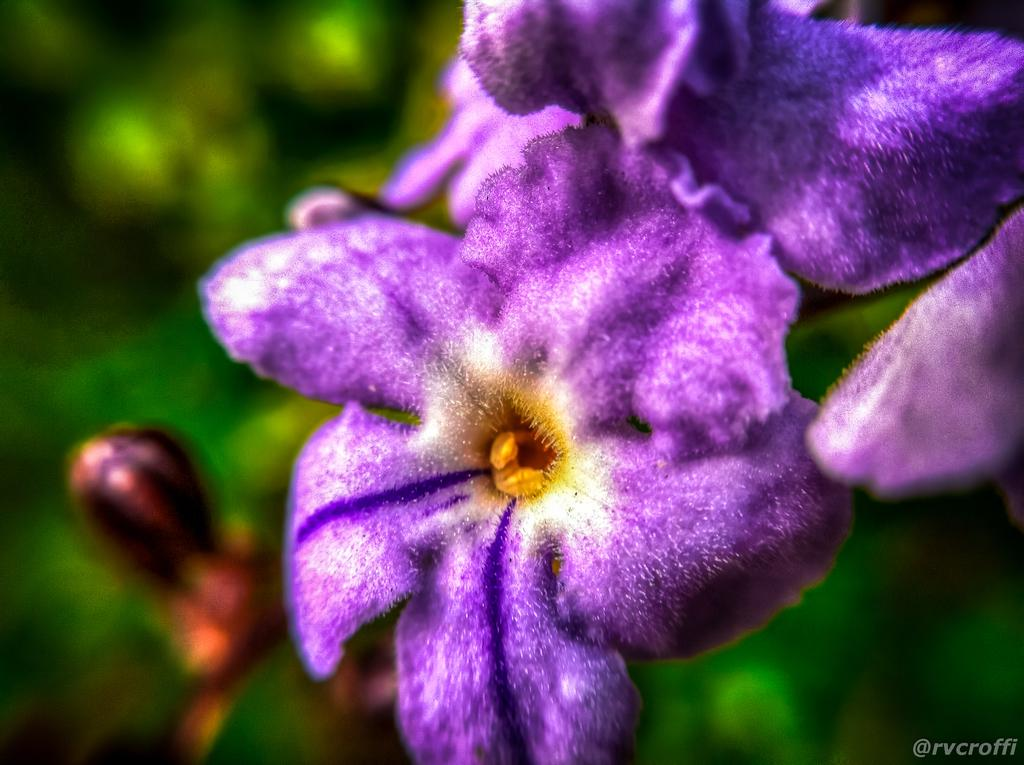What type of flora can be seen in the image? There are flowers in the image. What colors are the flowers? The flowers are purple, yellow, and cream in color. How would you describe the background of the image? The background of the image is blurry. What else can be seen in the background besides the flowers? There are plants visible in the background. How many brothers are depicted in the image? There are no people, including brothers, present in the image; it features flowers and plants. What type of wax is used to create the flowers in the image? The flowers in the image are real, not made of wax, so there is no wax used to create them. 